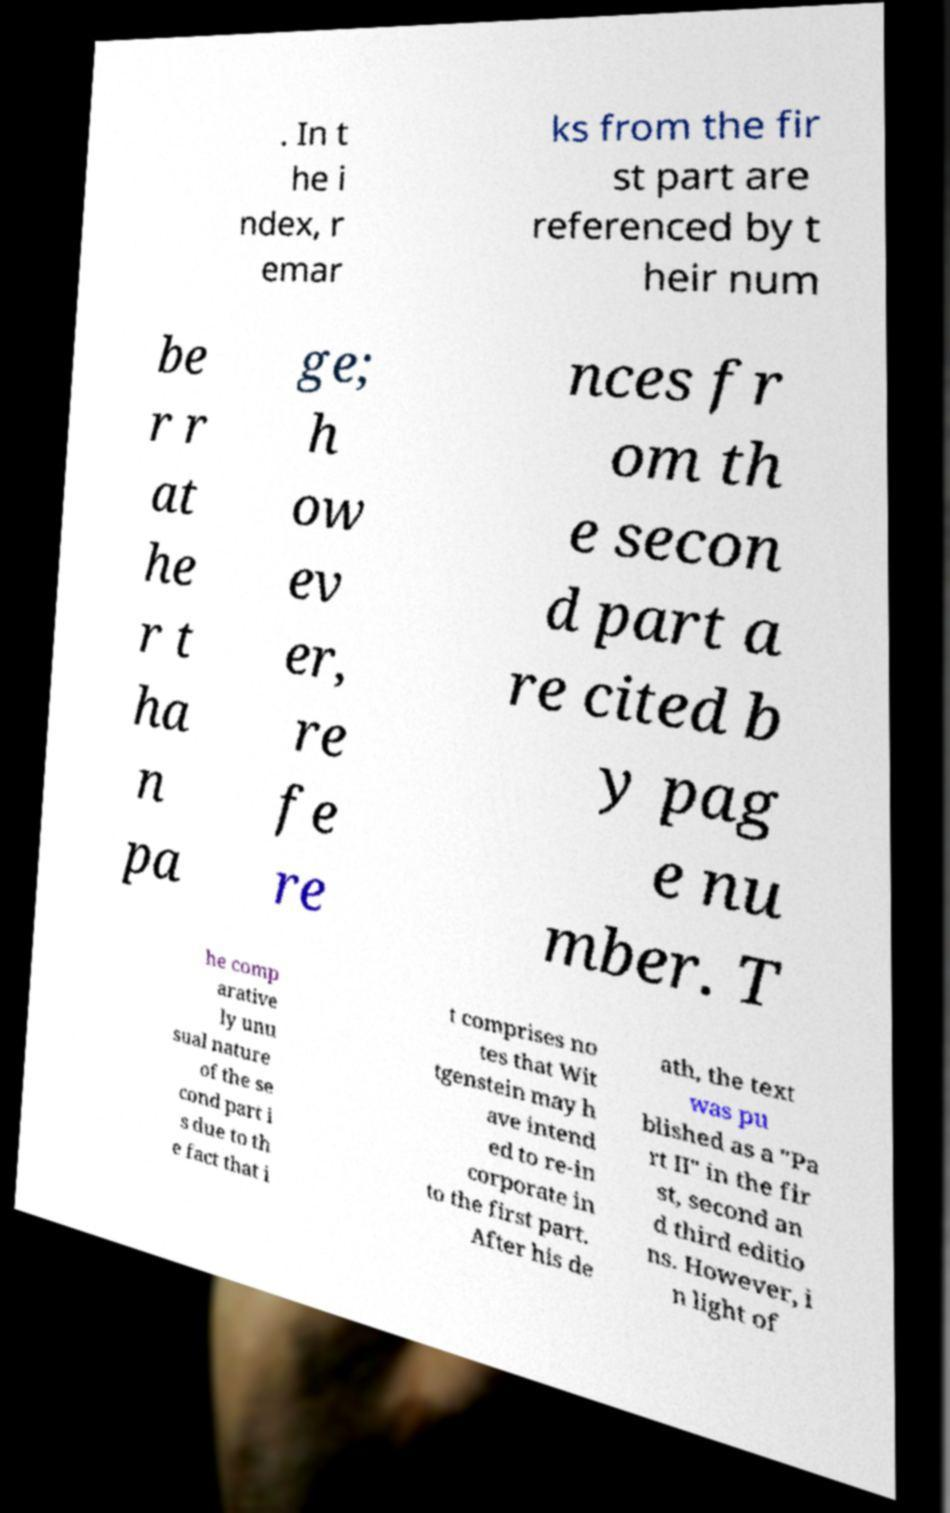Could you assist in decoding the text presented in this image and type it out clearly? . In t he i ndex, r emar ks from the fir st part are referenced by t heir num be r r at he r t ha n pa ge; h ow ev er, re fe re nces fr om th e secon d part a re cited b y pag e nu mber. T he comp arative ly unu sual nature of the se cond part i s due to th e fact that i t comprises no tes that Wit tgenstein may h ave intend ed to re-in corporate in to the first part. After his de ath, the text was pu blished as a "Pa rt II" in the fir st, second an d third editio ns. However, i n light of 